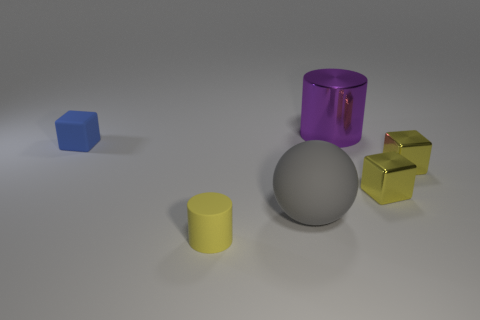Subtract all tiny yellow metallic blocks. How many blocks are left? 1 Subtract all yellow cylinders. How many cylinders are left? 1 Add 4 gray shiny cylinders. How many objects exist? 10 Subtract all cylinders. How many objects are left? 4 Subtract 1 cylinders. How many cylinders are left? 1 Subtract all cyan spheres. How many blue cubes are left? 1 Subtract all yellow cubes. Subtract all small rubber blocks. How many objects are left? 3 Add 6 matte balls. How many matte balls are left? 7 Add 2 small cyan matte cubes. How many small cyan matte cubes exist? 2 Subtract 0 cyan cylinders. How many objects are left? 6 